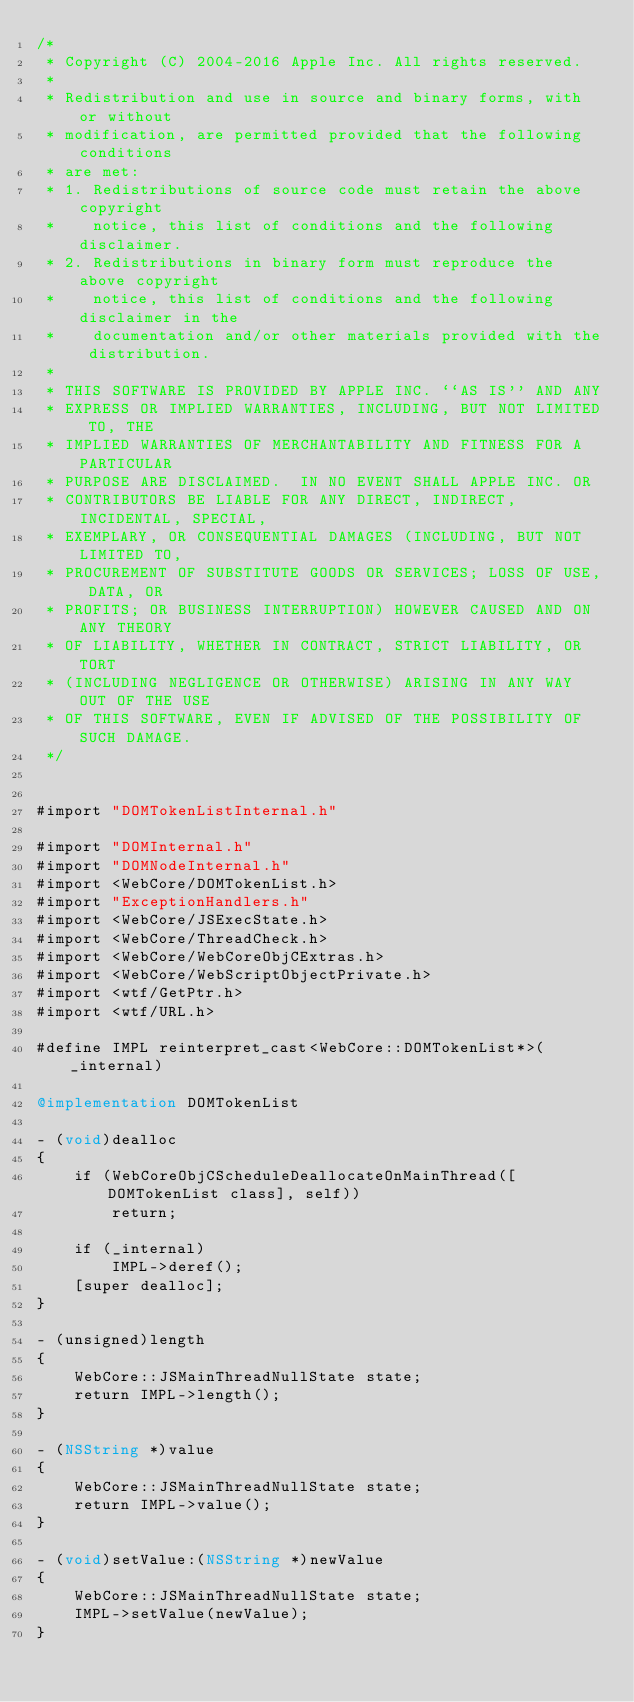<code> <loc_0><loc_0><loc_500><loc_500><_ObjectiveC_>/*
 * Copyright (C) 2004-2016 Apple Inc. All rights reserved.
 *
 * Redistribution and use in source and binary forms, with or without
 * modification, are permitted provided that the following conditions
 * are met:
 * 1. Redistributions of source code must retain the above copyright
 *    notice, this list of conditions and the following disclaimer.
 * 2. Redistributions in binary form must reproduce the above copyright
 *    notice, this list of conditions and the following disclaimer in the
 *    documentation and/or other materials provided with the distribution.
 *
 * THIS SOFTWARE IS PROVIDED BY APPLE INC. ``AS IS'' AND ANY
 * EXPRESS OR IMPLIED WARRANTIES, INCLUDING, BUT NOT LIMITED TO, THE
 * IMPLIED WARRANTIES OF MERCHANTABILITY AND FITNESS FOR A PARTICULAR
 * PURPOSE ARE DISCLAIMED.  IN NO EVENT SHALL APPLE INC. OR
 * CONTRIBUTORS BE LIABLE FOR ANY DIRECT, INDIRECT, INCIDENTAL, SPECIAL,
 * EXEMPLARY, OR CONSEQUENTIAL DAMAGES (INCLUDING, BUT NOT LIMITED TO,
 * PROCUREMENT OF SUBSTITUTE GOODS OR SERVICES; LOSS OF USE, DATA, OR
 * PROFITS; OR BUSINESS INTERRUPTION) HOWEVER CAUSED AND ON ANY THEORY
 * OF LIABILITY, WHETHER IN CONTRACT, STRICT LIABILITY, OR TORT
 * (INCLUDING NEGLIGENCE OR OTHERWISE) ARISING IN ANY WAY OUT OF THE USE
 * OF THIS SOFTWARE, EVEN IF ADVISED OF THE POSSIBILITY OF SUCH DAMAGE.
 */


#import "DOMTokenListInternal.h"

#import "DOMInternal.h"
#import "DOMNodeInternal.h"
#import <WebCore/DOMTokenList.h>
#import "ExceptionHandlers.h"
#import <WebCore/JSExecState.h>
#import <WebCore/ThreadCheck.h>
#import <WebCore/WebCoreObjCExtras.h>
#import <WebCore/WebScriptObjectPrivate.h>
#import <wtf/GetPtr.h>
#import <wtf/URL.h>

#define IMPL reinterpret_cast<WebCore::DOMTokenList*>(_internal)

@implementation DOMTokenList

- (void)dealloc
{
    if (WebCoreObjCScheduleDeallocateOnMainThread([DOMTokenList class], self))
        return;

    if (_internal)
        IMPL->deref();
    [super dealloc];
}

- (unsigned)length
{
    WebCore::JSMainThreadNullState state;
    return IMPL->length();
}

- (NSString *)value
{
    WebCore::JSMainThreadNullState state;
    return IMPL->value();
}

- (void)setValue:(NSString *)newValue
{
    WebCore::JSMainThreadNullState state;
    IMPL->setValue(newValue);
}
</code> 